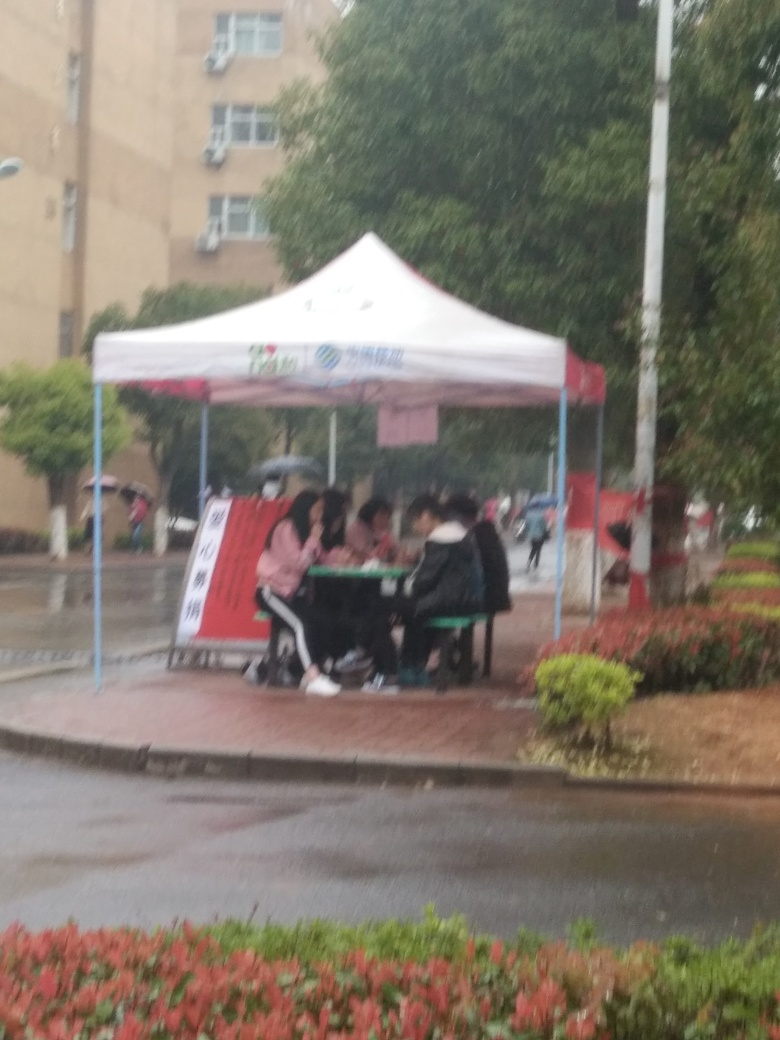How does the setting affect the mood of the photo? The overcast sky and wet ground suggest a somber or calm mood, with the people finding a makeshift community under the tent, adding a sense of togetherness or resilience amidst less than ideal weather conditions. 